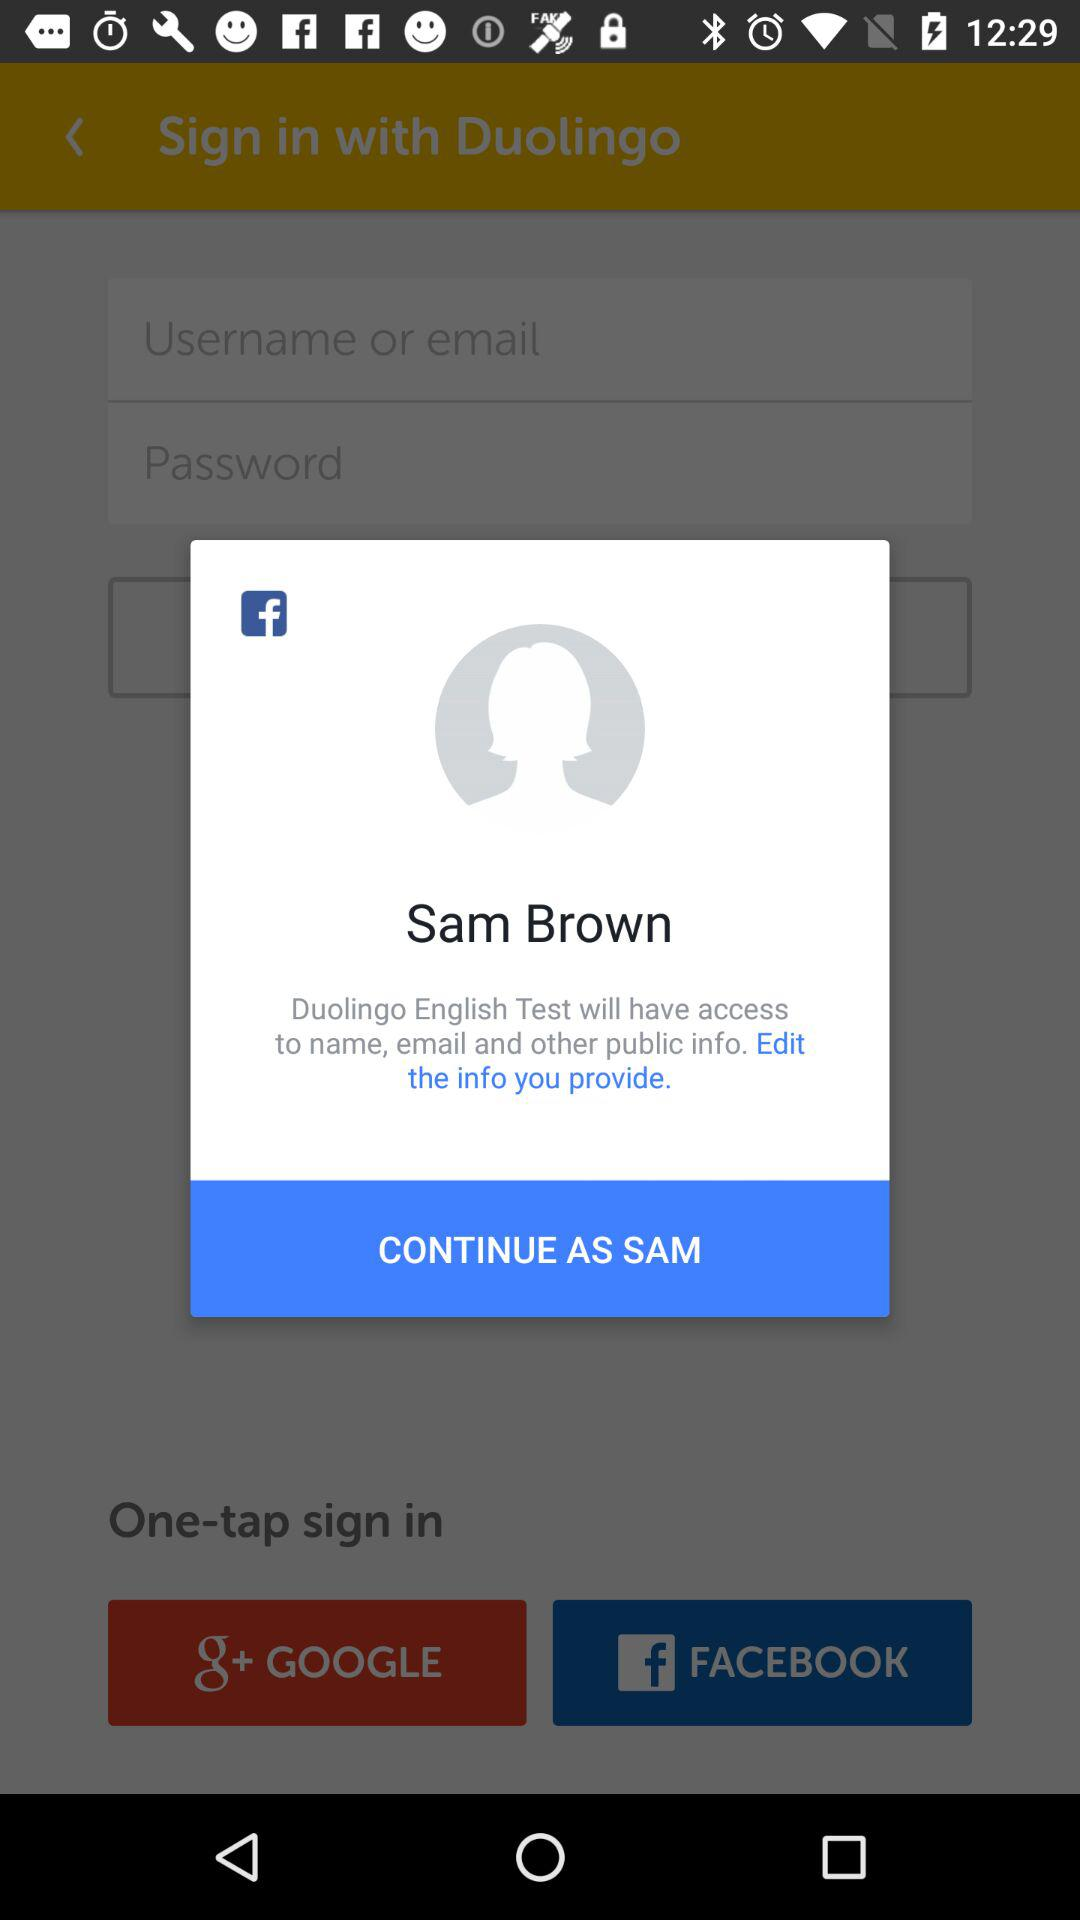What is the name of the person logging in? The name of the person is Sam Brown. 